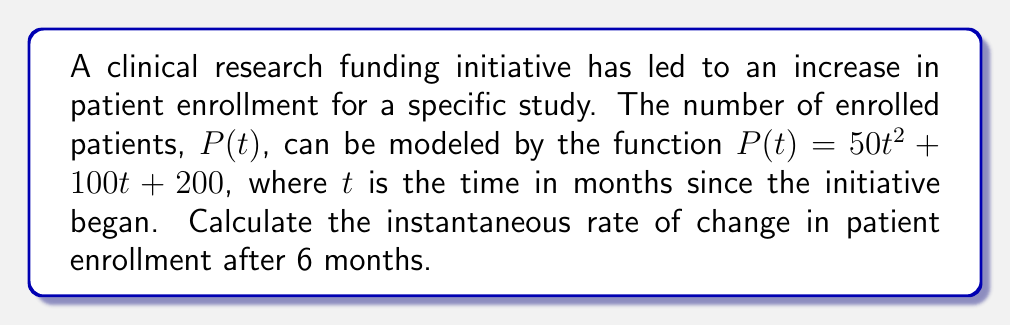Could you help me with this problem? To find the instantaneous rate of change in patient enrollment after 6 months, we need to calculate the derivative of the function $P(t)$ and evaluate it at $t=6$. Here's the step-by-step process:

1. The given function is $P(t) = 50t^2 + 100t + 200$

2. To find the rate of change, we need to find $P'(t)$:
   $P'(t) = \frac{d}{dt}(50t^2 + 100t + 200)$

3. Using the power rule and constant rule of differentiation:
   $P'(t) = 100t + 100$

4. Now, we need to evaluate $P'(t)$ at $t=6$:
   $P'(6) = 100(6) + 100$
   $P'(6) = 600 + 100 = 700$

5. The units of this rate are patients per month, as $t$ is measured in months.
Answer: 700 patients/month 